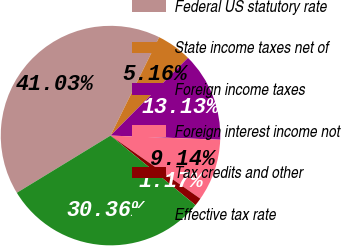Convert chart to OTSL. <chart><loc_0><loc_0><loc_500><loc_500><pie_chart><fcel>Federal US statutory rate<fcel>State income taxes net of<fcel>Foreign income taxes<fcel>Foreign interest income not<fcel>Tax credits and other<fcel>Effective tax rate<nl><fcel>41.03%<fcel>5.16%<fcel>13.13%<fcel>9.14%<fcel>1.17%<fcel>30.36%<nl></chart> 